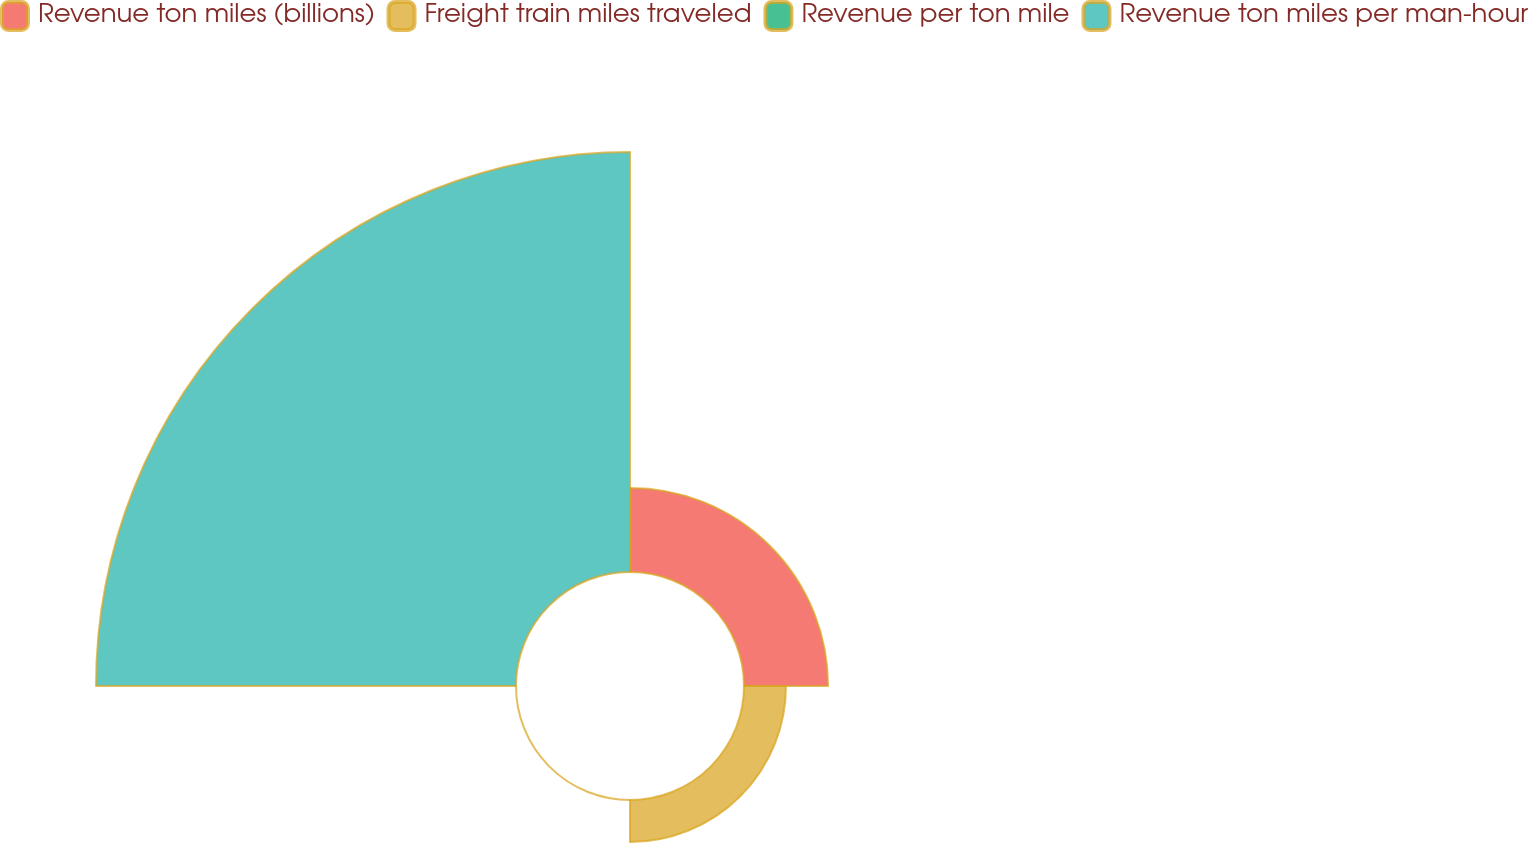<chart> <loc_0><loc_0><loc_500><loc_500><pie_chart><fcel>Revenue ton miles (billions)<fcel>Freight train miles traveled<fcel>Revenue per ton mile<fcel>Revenue ton miles per man-hour<nl><fcel>15.39%<fcel>7.69%<fcel>0.0%<fcel>76.92%<nl></chart> 